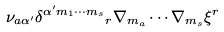Convert formula to latex. <formula><loc_0><loc_0><loc_500><loc_500>\nu _ { a \alpha ^ { \prime } } \delta ^ { \alpha ^ { \prime } m _ { 1 } \cdots m _ { s } } { _ { r } } \nabla _ { m _ { a } } \cdots \nabla _ { m _ { s } } \xi ^ { r }</formula> 